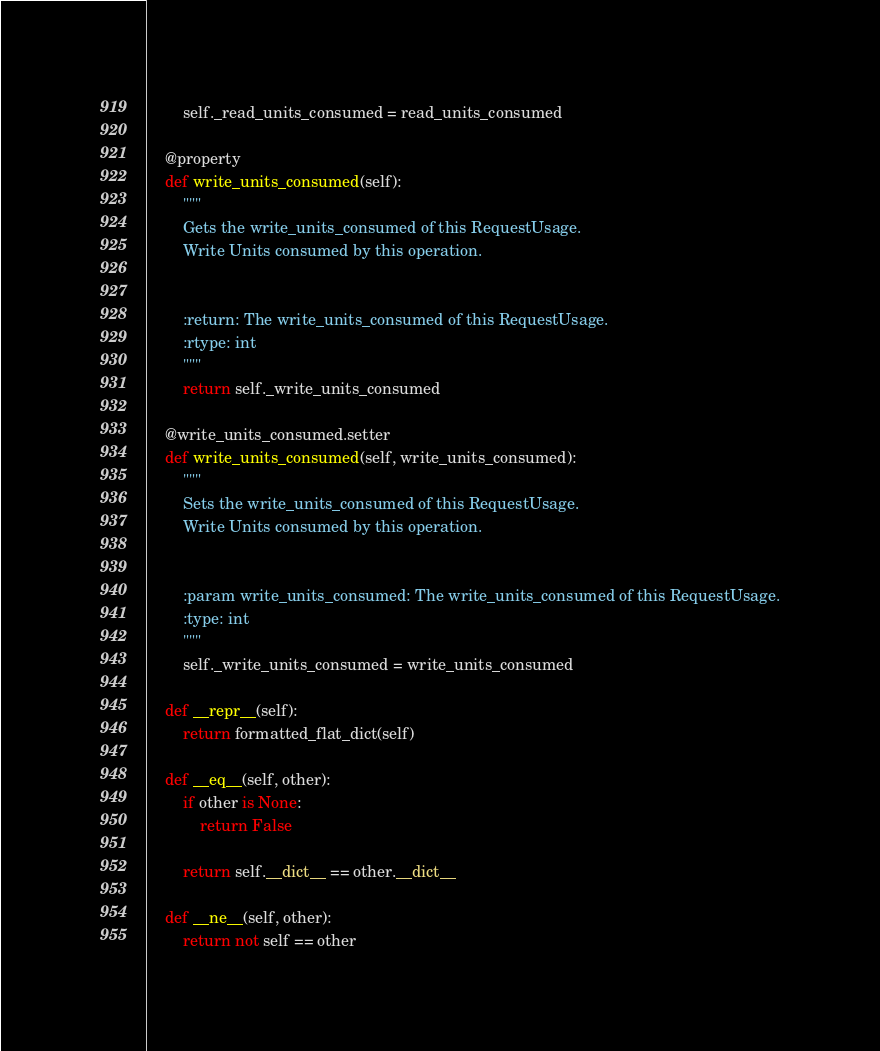Convert code to text. <code><loc_0><loc_0><loc_500><loc_500><_Python_>        self._read_units_consumed = read_units_consumed

    @property
    def write_units_consumed(self):
        """
        Gets the write_units_consumed of this RequestUsage.
        Write Units consumed by this operation.


        :return: The write_units_consumed of this RequestUsage.
        :rtype: int
        """
        return self._write_units_consumed

    @write_units_consumed.setter
    def write_units_consumed(self, write_units_consumed):
        """
        Sets the write_units_consumed of this RequestUsage.
        Write Units consumed by this operation.


        :param write_units_consumed: The write_units_consumed of this RequestUsage.
        :type: int
        """
        self._write_units_consumed = write_units_consumed

    def __repr__(self):
        return formatted_flat_dict(self)

    def __eq__(self, other):
        if other is None:
            return False

        return self.__dict__ == other.__dict__

    def __ne__(self, other):
        return not self == other
</code> 